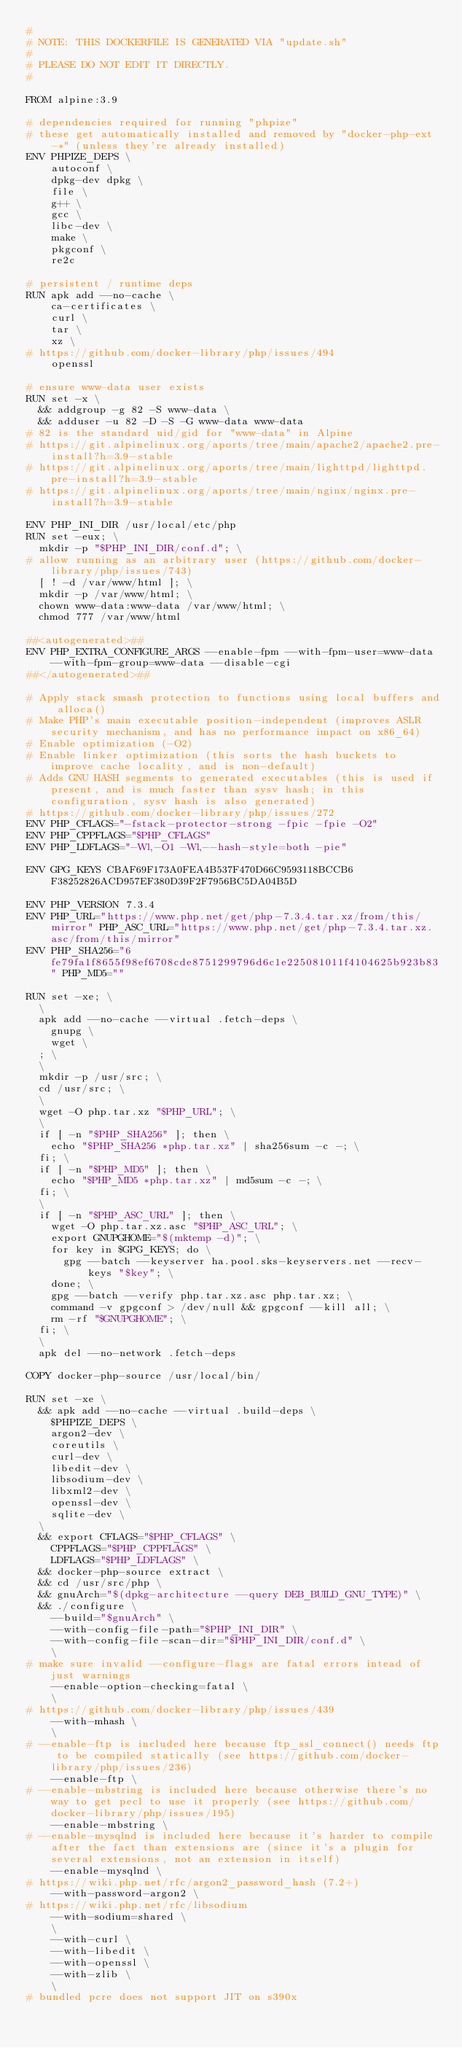Convert code to text. <code><loc_0><loc_0><loc_500><loc_500><_Dockerfile_>#
# NOTE: THIS DOCKERFILE IS GENERATED VIA "update.sh"
#
# PLEASE DO NOT EDIT IT DIRECTLY.
#

FROM alpine:3.9

# dependencies required for running "phpize"
# these get automatically installed and removed by "docker-php-ext-*" (unless they're already installed)
ENV PHPIZE_DEPS \
		autoconf \
		dpkg-dev dpkg \
		file \
		g++ \
		gcc \
		libc-dev \
		make \
		pkgconf \
		re2c

# persistent / runtime deps
RUN apk add --no-cache \
		ca-certificates \
		curl \
		tar \
		xz \
# https://github.com/docker-library/php/issues/494
		openssl

# ensure www-data user exists
RUN set -x \
	&& addgroup -g 82 -S www-data \
	&& adduser -u 82 -D -S -G www-data www-data
# 82 is the standard uid/gid for "www-data" in Alpine
# https://git.alpinelinux.org/aports/tree/main/apache2/apache2.pre-install?h=3.9-stable
# https://git.alpinelinux.org/aports/tree/main/lighttpd/lighttpd.pre-install?h=3.9-stable
# https://git.alpinelinux.org/aports/tree/main/nginx/nginx.pre-install?h=3.9-stable

ENV PHP_INI_DIR /usr/local/etc/php
RUN set -eux; \
	mkdir -p "$PHP_INI_DIR/conf.d"; \
# allow running as an arbitrary user (https://github.com/docker-library/php/issues/743)
	[ ! -d /var/www/html ]; \
	mkdir -p /var/www/html; \
	chown www-data:www-data /var/www/html; \
	chmod 777 /var/www/html

##<autogenerated>##
ENV PHP_EXTRA_CONFIGURE_ARGS --enable-fpm --with-fpm-user=www-data --with-fpm-group=www-data --disable-cgi
##</autogenerated>##

# Apply stack smash protection to functions using local buffers and alloca()
# Make PHP's main executable position-independent (improves ASLR security mechanism, and has no performance impact on x86_64)
# Enable optimization (-O2)
# Enable linker optimization (this sorts the hash buckets to improve cache locality, and is non-default)
# Adds GNU HASH segments to generated executables (this is used if present, and is much faster than sysv hash; in this configuration, sysv hash is also generated)
# https://github.com/docker-library/php/issues/272
ENV PHP_CFLAGS="-fstack-protector-strong -fpic -fpie -O2"
ENV PHP_CPPFLAGS="$PHP_CFLAGS"
ENV PHP_LDFLAGS="-Wl,-O1 -Wl,--hash-style=both -pie"

ENV GPG_KEYS CBAF69F173A0FEA4B537F470D66C9593118BCCB6 F38252826ACD957EF380D39F2F7956BC5DA04B5D

ENV PHP_VERSION 7.3.4
ENV PHP_URL="https://www.php.net/get/php-7.3.4.tar.xz/from/this/mirror" PHP_ASC_URL="https://www.php.net/get/php-7.3.4.tar.xz.asc/from/this/mirror"
ENV PHP_SHA256="6fe79fa1f8655f98ef6708cde8751299796d6c1e225081011f4104625b923b83" PHP_MD5=""

RUN set -xe; \
	\
	apk add --no-cache --virtual .fetch-deps \
		gnupg \
		wget \
	; \
	\
	mkdir -p /usr/src; \
	cd /usr/src; \
	\
	wget -O php.tar.xz "$PHP_URL"; \
	\
	if [ -n "$PHP_SHA256" ]; then \
		echo "$PHP_SHA256 *php.tar.xz" | sha256sum -c -; \
	fi; \
	if [ -n "$PHP_MD5" ]; then \
		echo "$PHP_MD5 *php.tar.xz" | md5sum -c -; \
	fi; \
	\
	if [ -n "$PHP_ASC_URL" ]; then \
		wget -O php.tar.xz.asc "$PHP_ASC_URL"; \
		export GNUPGHOME="$(mktemp -d)"; \
		for key in $GPG_KEYS; do \
			gpg --batch --keyserver ha.pool.sks-keyservers.net --recv-keys "$key"; \
		done; \
		gpg --batch --verify php.tar.xz.asc php.tar.xz; \
		command -v gpgconf > /dev/null && gpgconf --kill all; \
		rm -rf "$GNUPGHOME"; \
	fi; \
	\
	apk del --no-network .fetch-deps

COPY docker-php-source /usr/local/bin/

RUN set -xe \
	&& apk add --no-cache --virtual .build-deps \
		$PHPIZE_DEPS \
		argon2-dev \
		coreutils \
		curl-dev \
		libedit-dev \
		libsodium-dev \
		libxml2-dev \
		openssl-dev \
		sqlite-dev \
	\
	&& export CFLAGS="$PHP_CFLAGS" \
		CPPFLAGS="$PHP_CPPFLAGS" \
		LDFLAGS="$PHP_LDFLAGS" \
	&& docker-php-source extract \
	&& cd /usr/src/php \
	&& gnuArch="$(dpkg-architecture --query DEB_BUILD_GNU_TYPE)" \
	&& ./configure \
		--build="$gnuArch" \
		--with-config-file-path="$PHP_INI_DIR" \
		--with-config-file-scan-dir="$PHP_INI_DIR/conf.d" \
		\
# make sure invalid --configure-flags are fatal errors intead of just warnings
		--enable-option-checking=fatal \
		\
# https://github.com/docker-library/php/issues/439
		--with-mhash \
		\
# --enable-ftp is included here because ftp_ssl_connect() needs ftp to be compiled statically (see https://github.com/docker-library/php/issues/236)
		--enable-ftp \
# --enable-mbstring is included here because otherwise there's no way to get pecl to use it properly (see https://github.com/docker-library/php/issues/195)
		--enable-mbstring \
# --enable-mysqlnd is included here because it's harder to compile after the fact than extensions are (since it's a plugin for several extensions, not an extension in itself)
		--enable-mysqlnd \
# https://wiki.php.net/rfc/argon2_password_hash (7.2+)
		--with-password-argon2 \
# https://wiki.php.net/rfc/libsodium
		--with-sodium=shared \
		\
		--with-curl \
		--with-libedit \
		--with-openssl \
		--with-zlib \
		\
# bundled pcre does not support JIT on s390x</code> 